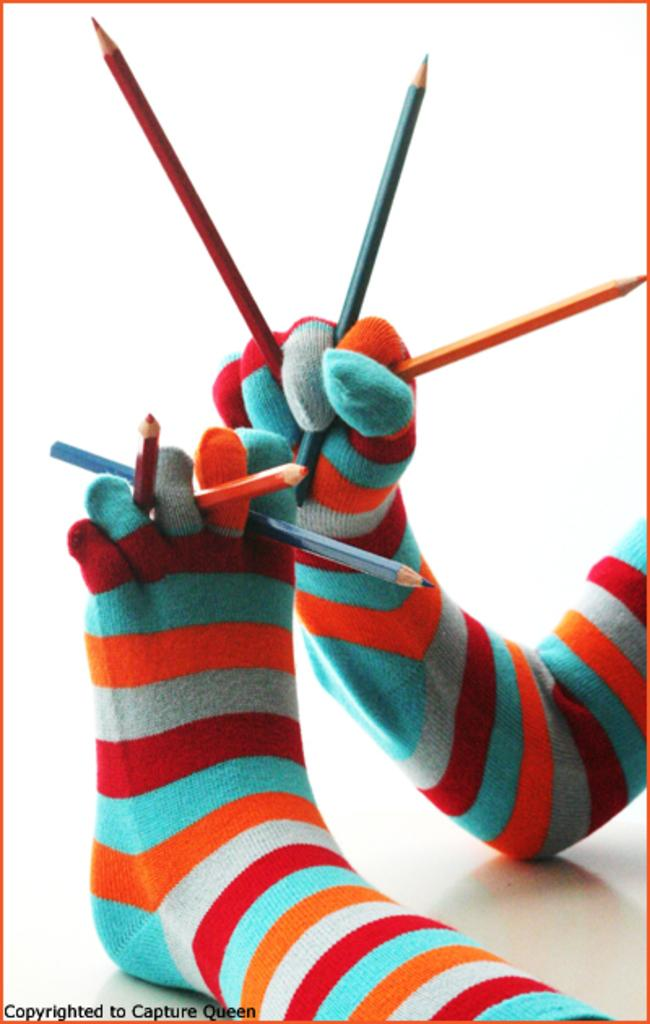What is the hand in the image holding? The hand in the image is holding pencils. What else is holding pencils in the image? The leg with socks is also holding pencils. Can you describe the leg in the image? The leg has socks on it. Where is the text located in the image? The text is in the bottom left corner of the image. What type of muscle is being exercised by the actor in the image? There is no actor or muscle exercise depicted in the image; it features a hand and a leg holding pencils, along with some text. What type of acoustics can be heard in the image? There is no sound or acoustics present in the image; it is a static visual representation. 